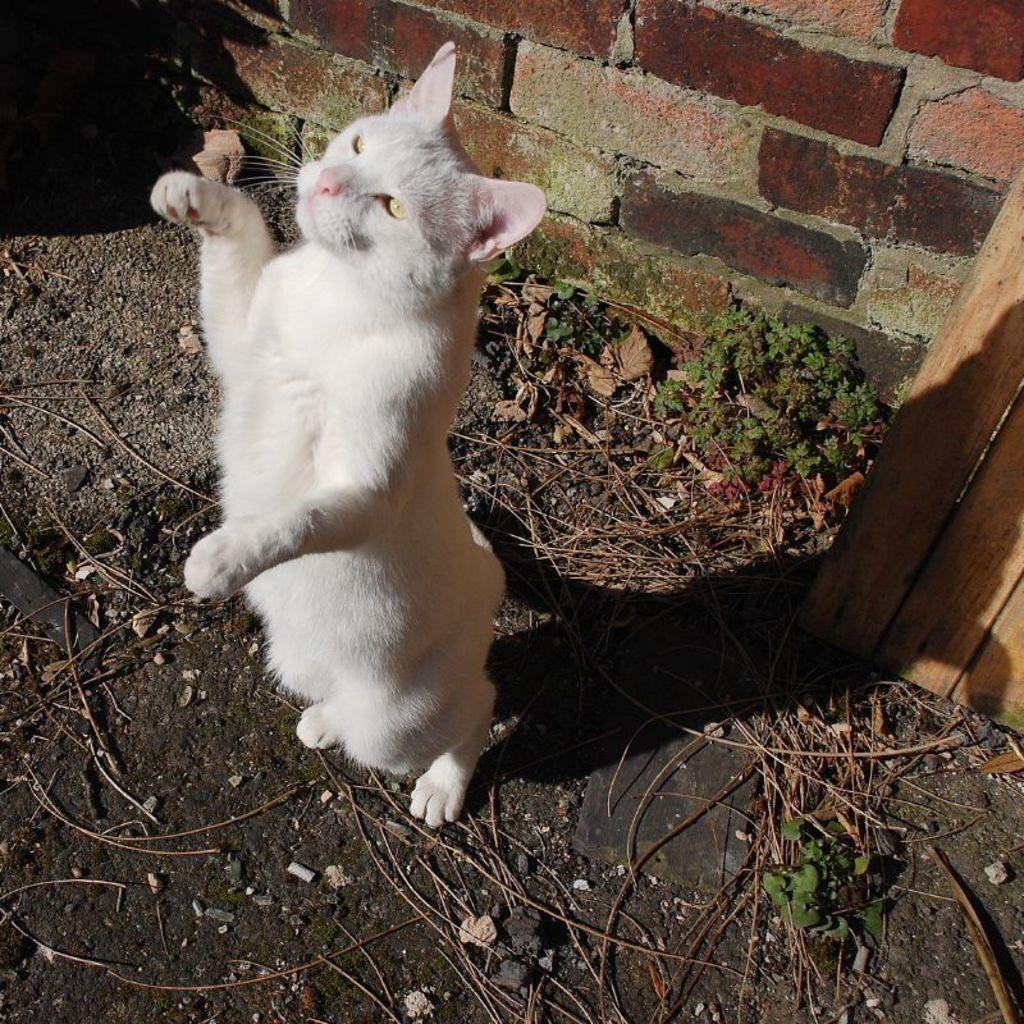Could you give a brief overview of what you see in this image? In this image I can see the cat and the cat is in white color, background I can see plants in green color and the wall is in brown and gray color. 